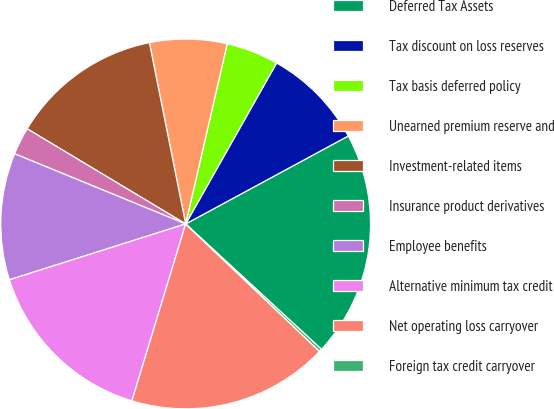Convert chart. <chart><loc_0><loc_0><loc_500><loc_500><pie_chart><fcel>Deferred Tax Assets<fcel>Tax discount on loss reserves<fcel>Tax basis deferred policy<fcel>Unearned premium reserve and<fcel>Investment-related items<fcel>Insurance product derivatives<fcel>Employee benefits<fcel>Alternative minimum tax credit<fcel>Net operating loss carryover<fcel>Foreign tax credit carryover<nl><fcel>19.76%<fcel>8.92%<fcel>4.58%<fcel>6.75%<fcel>13.25%<fcel>2.41%<fcel>11.08%<fcel>15.42%<fcel>17.59%<fcel>0.24%<nl></chart> 